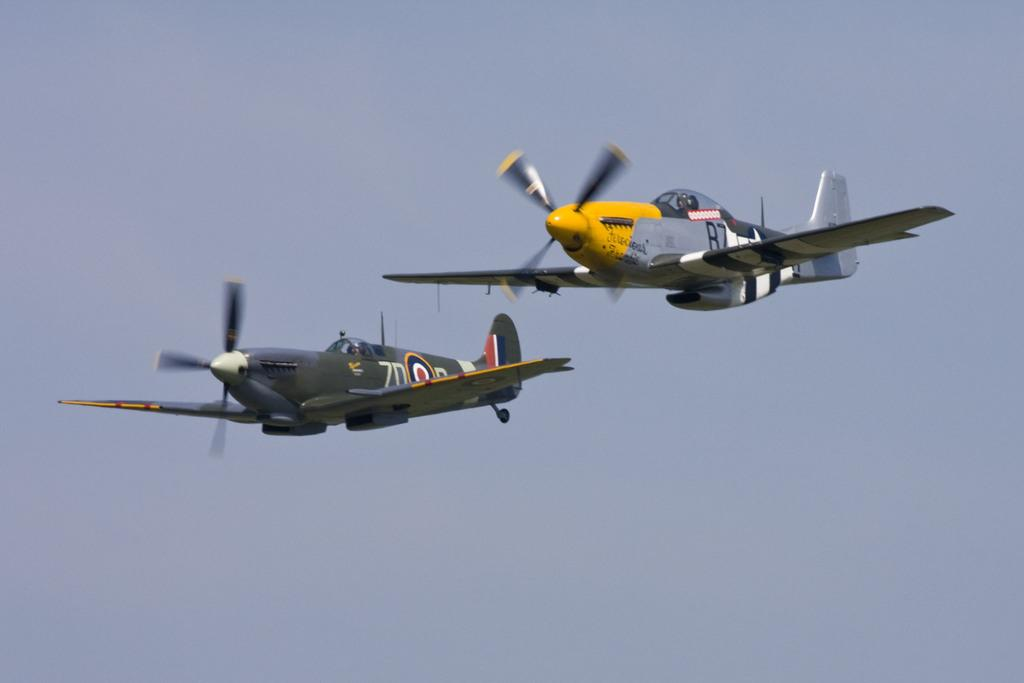Provide a one-sentence caption for the provided image. Two planes, one marked R7, fly side by side. 